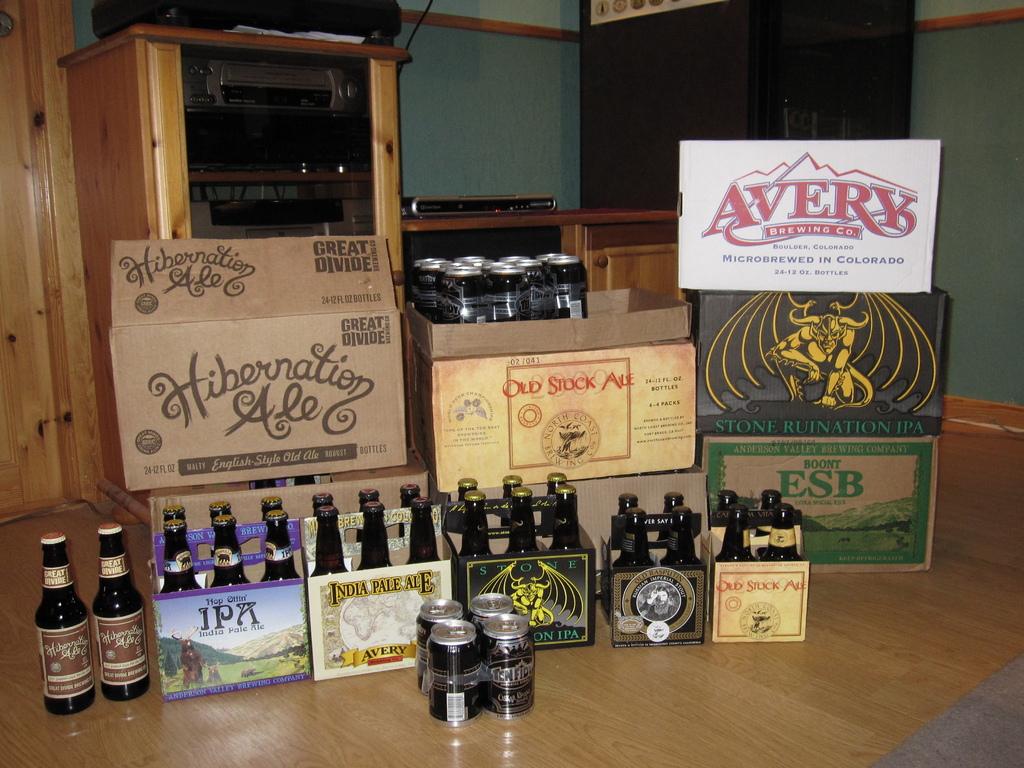What is the name of one of the brands?
Provide a short and direct response. Avery. Where is avery microbrewed?
Make the answer very short. Colorado. 